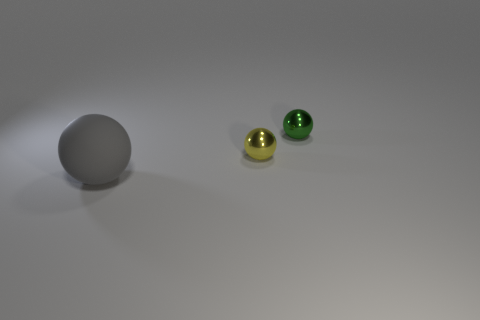Subtract all green metallic balls. How many balls are left? 2 Add 2 tiny brown cylinders. How many objects exist? 5 Subtract 3 balls. How many balls are left? 0 Add 1 large gray rubber balls. How many large gray rubber balls are left? 2 Add 2 spheres. How many spheres exist? 5 Subtract 0 blue cylinders. How many objects are left? 3 Subtract all yellow spheres. Subtract all red cubes. How many spheres are left? 2 Subtract all blue blocks. How many blue spheres are left? 0 Subtract all large matte cubes. Subtract all large matte things. How many objects are left? 2 